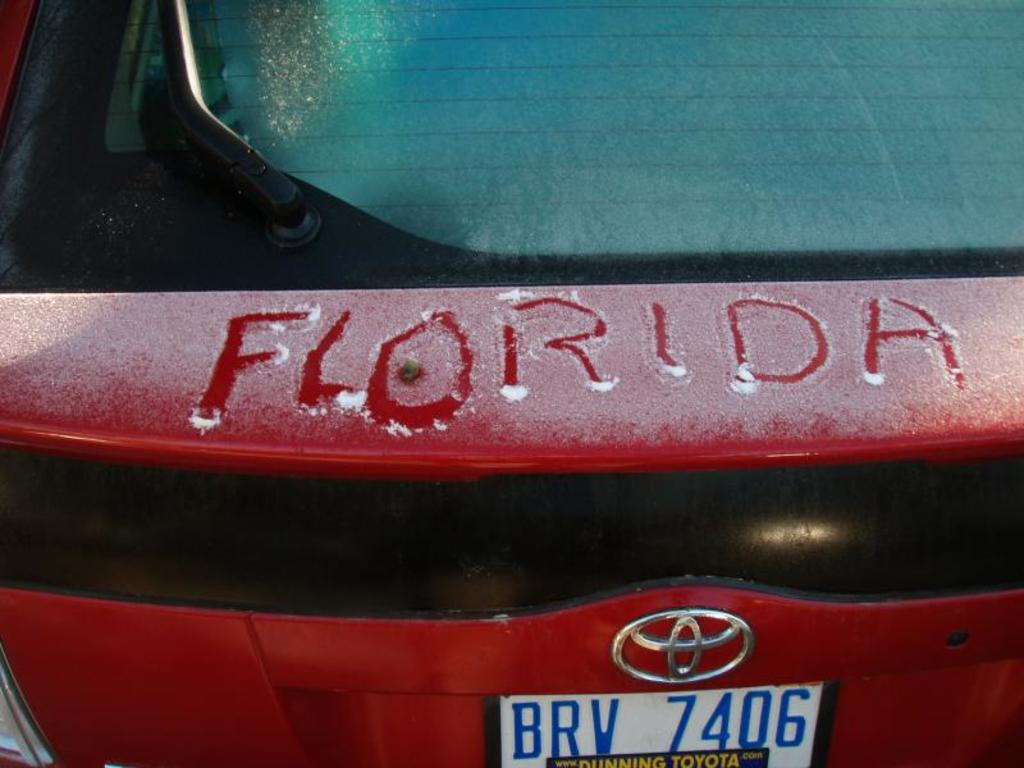What do you think is going on in this snapshot?
 The image captures a moment on a chilly day, featuring the rear of a red Toyota car. The frost-kissed rear window suggests the cold weather. A playful hand has taken advantage of the snowy conditions to write "Florida" on the trunk, perhaps longing for warmer climates. The car's license plate reads "BRV 7406", providing a unique identifier in the sea of vehicles. 